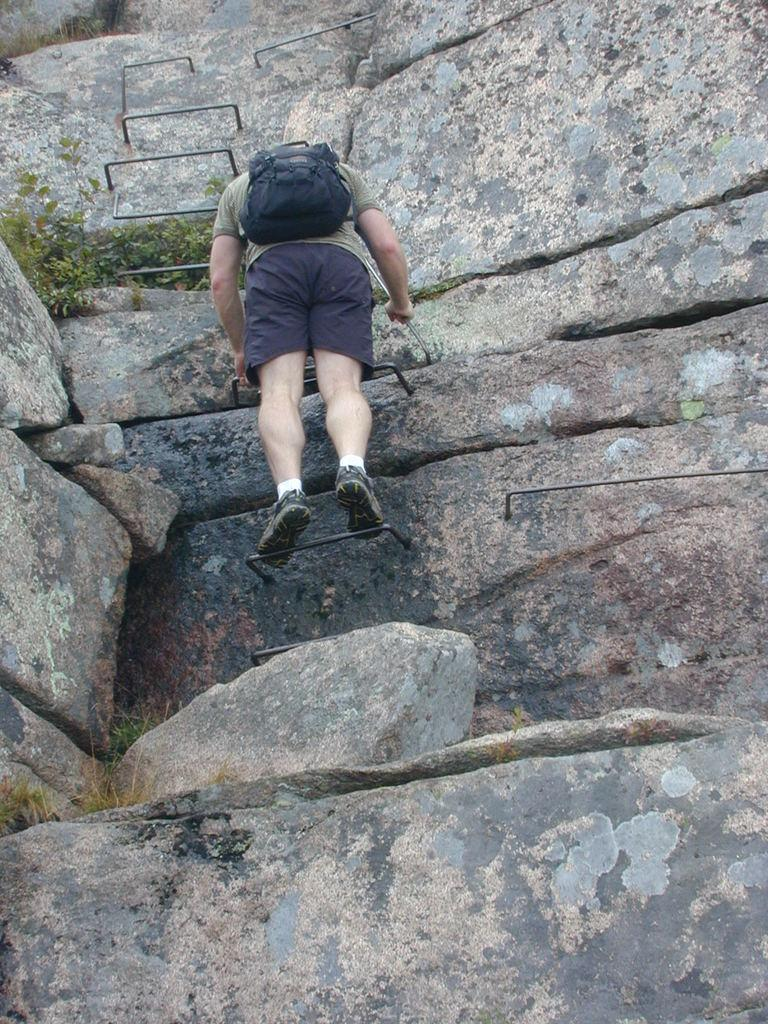What geographical feature is present in the picture? There is a hill or a mountain in the picture. What is the person in the picture doing? The person is climbing in the picture. What is the person using to assist with the climb? The person is using an iron object for assistance. What type of vegetation can be seen on the left side of the picture? There are plants on the left side of the picture. Can you see any waves crashing against the bridge in the picture? There is no bridge or waves present in the picture; it features a person climbing a hill or mountain with the assistance of an iron object. 